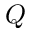Convert formula to latex. <formula><loc_0><loc_0><loc_500><loc_500>Q</formula> 